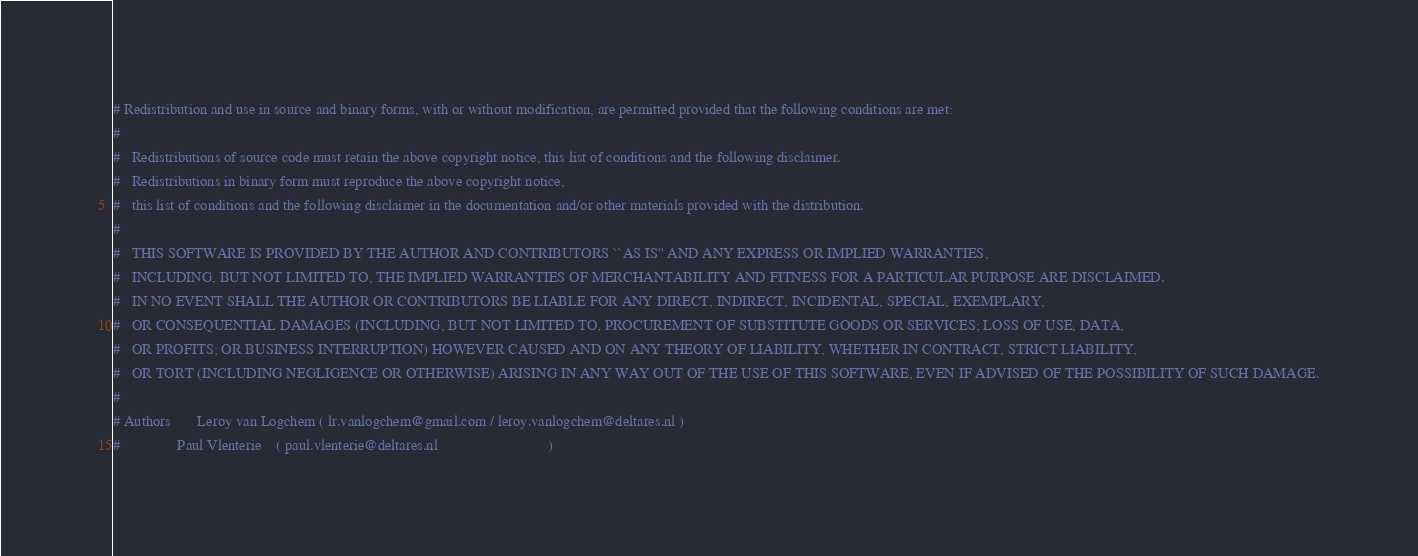Convert code to text. <code><loc_0><loc_0><loc_500><loc_500><_Bash_># Redistribution and use in source and binary forms, with or without modification, are permitted provided that the following conditions are met:
#
#   Redistributions of source code must retain the above copyright notice, this list of conditions and the following disclaimer.
#   Redistributions in binary form must reproduce the above copyright notice,
#   this list of conditions and the following disclaimer in the documentation and/or other materials provided with the distribution.
#
#   THIS SOFTWARE IS PROVIDED BY THE AUTHOR AND CONTRIBUTORS ``AS IS'' AND ANY EXPRESS OR IMPLIED WARRANTIES,
#   INCLUDING, BUT NOT LIMITED TO, THE IMPLIED WARRANTIES OF MERCHANTABILITY AND FITNESS FOR A PARTICULAR PURPOSE ARE DISCLAIMED.
#   IN NO EVENT SHALL THE AUTHOR OR CONTRIBUTORS BE LIABLE FOR ANY DIRECT, INDIRECT, INCIDENTAL, SPECIAL, EXEMPLARY,
#   OR CONSEQUENTIAL DAMAGES (INCLUDING, BUT NOT LIMITED TO, PROCUREMENT OF SUBSTITUTE GOODS OR SERVICES; LOSS OF USE, DATA,
#   OR PROFITS; OR BUSINESS INTERRUPTION) HOWEVER CAUSED AND ON ANY THEORY OF LIABILITY, WHETHER IN CONTRACT, STRICT LIABILITY,
#   OR TORT (INCLUDING NEGLIGENCE OR OTHERWISE) ARISING IN ANY WAY OUT OF THE USE OF THIS SOFTWARE, EVEN IF ADVISED OF THE POSSIBILITY OF SUCH DAMAGE.
#
# Authors       Leroy van Logchem ( lr.vanlogchem@gmail.com / leroy.vanlogchem@deltares.nl )
#               Paul Vlenterie    ( paul.vlenterie@deltares.nl                             )</code> 